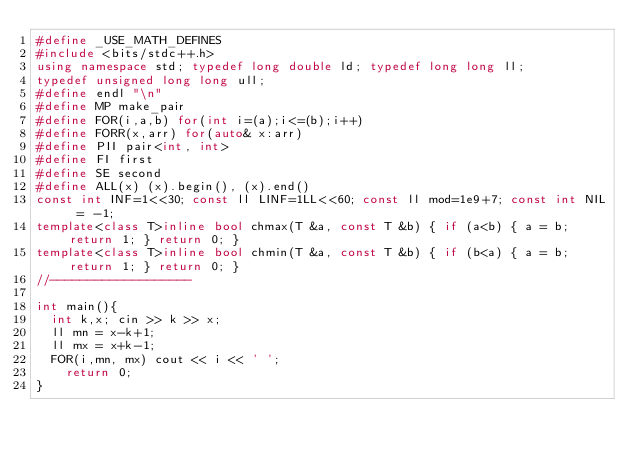Convert code to text. <code><loc_0><loc_0><loc_500><loc_500><_C++_>#define _USE_MATH_DEFINES
#include <bits/stdc++.h>
using namespace std; typedef long double ld; typedef long long ll;
typedef unsigned long long ull;
#define endl "\n"
#define MP make_pair
#define FOR(i,a,b) for(int i=(a);i<=(b);i++)
#define FORR(x,arr) for(auto& x:arr)
#define PII pair<int, int>
#define FI first 
#define SE second
#define ALL(x) (x).begin(), (x).end()
const int INF=1<<30; const ll LINF=1LL<<60; const ll mod=1e9+7; const int NIL = -1;
template<class T>inline bool chmax(T &a, const T &b) { if (a<b) { a = b; return 1; } return 0; }
template<class T>inline bool chmin(T &a, const T &b) { if (b<a) { a = b; return 1; } return 0; }
//-------------------

int main(){
	int k,x; cin >> k >> x;
	ll mn = x-k+1;
	ll mx = x+k-1;
	FOR(i,mn, mx) cout << i << ' ';
    return 0;
}
</code> 